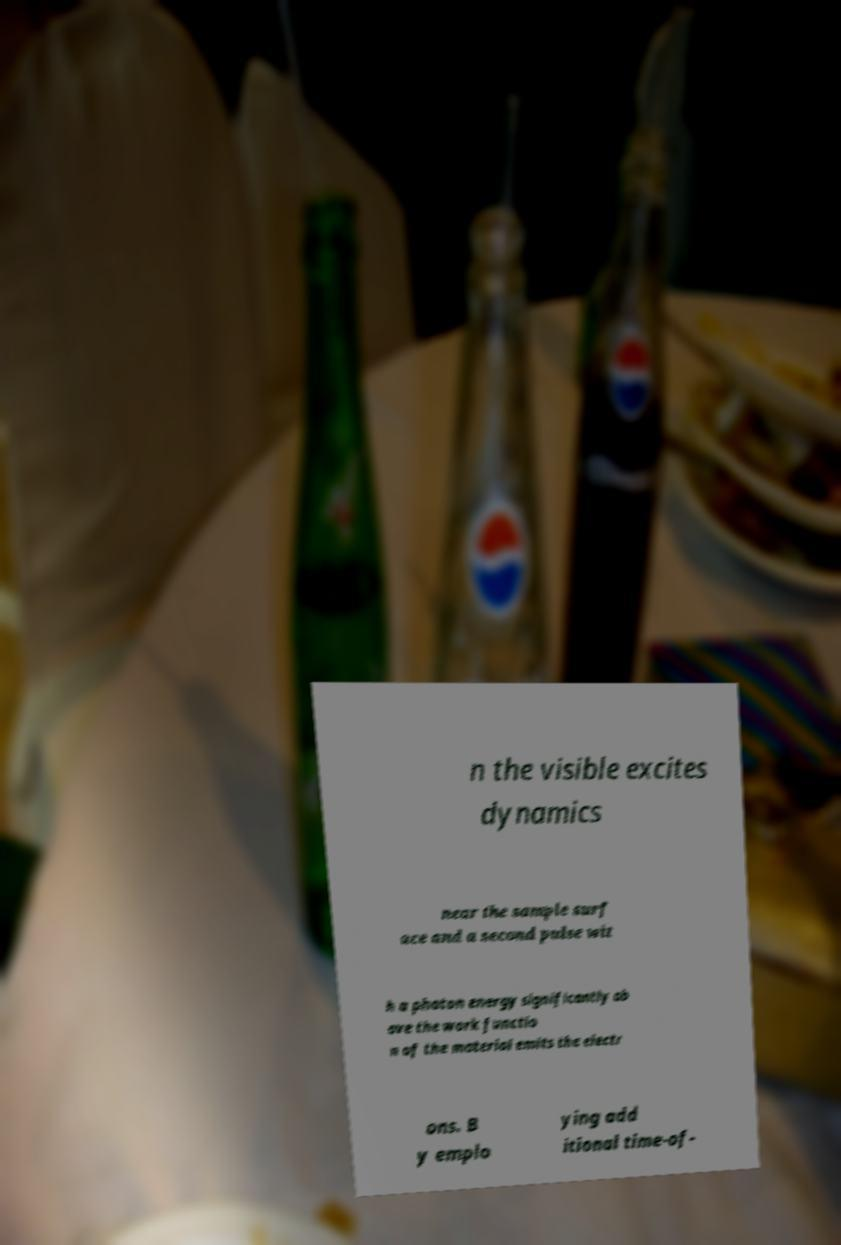There's text embedded in this image that I need extracted. Can you transcribe it verbatim? n the visible excites dynamics near the sample surf ace and a second pulse wit h a photon energy significantly ab ove the work functio n of the material emits the electr ons. B y emplo ying add itional time-of- 